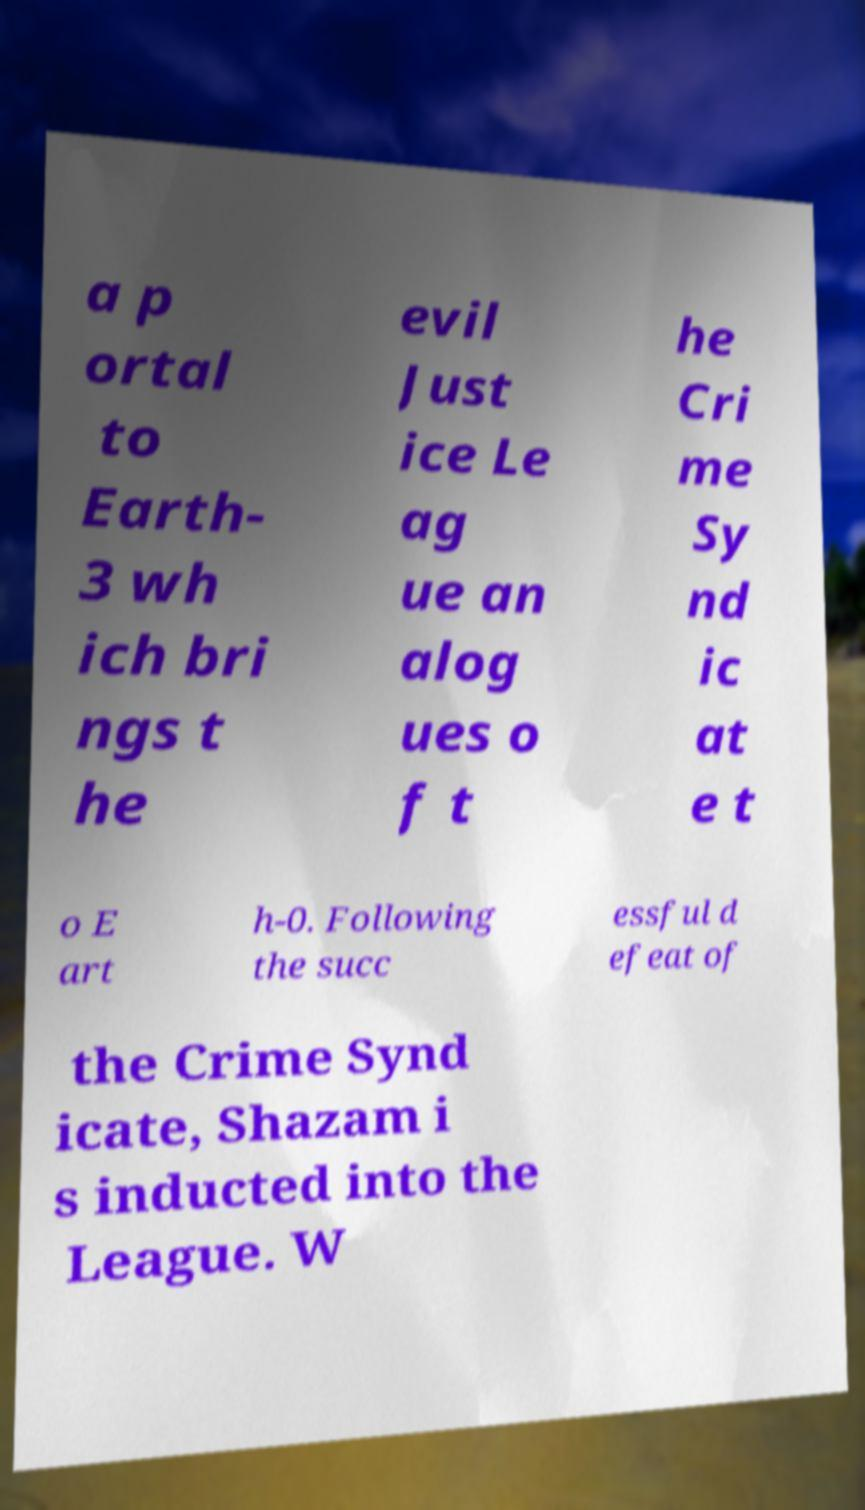Please identify and transcribe the text found in this image. a p ortal to Earth- 3 wh ich bri ngs t he evil Just ice Le ag ue an alog ues o f t he Cri me Sy nd ic at e t o E art h-0. Following the succ essful d efeat of the Crime Synd icate, Shazam i s inducted into the League. W 